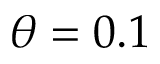<formula> <loc_0><loc_0><loc_500><loc_500>\theta = 0 . 1</formula> 